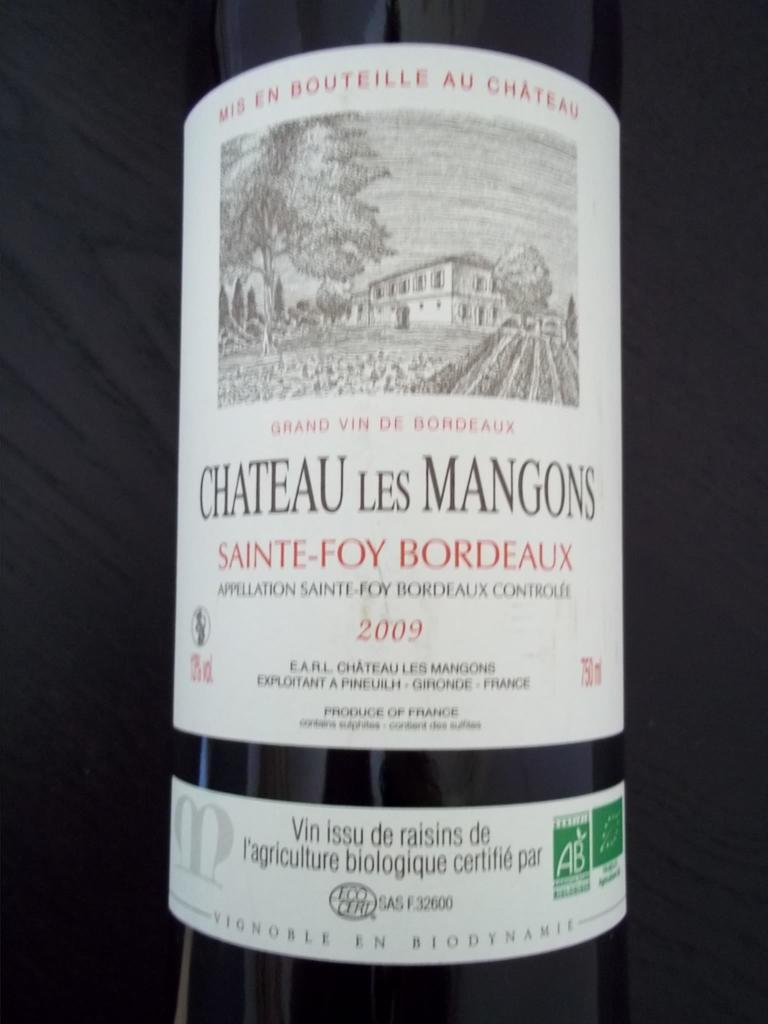<image>
Share a concise interpretation of the image provided. the word chateau that is on a wine bottle 